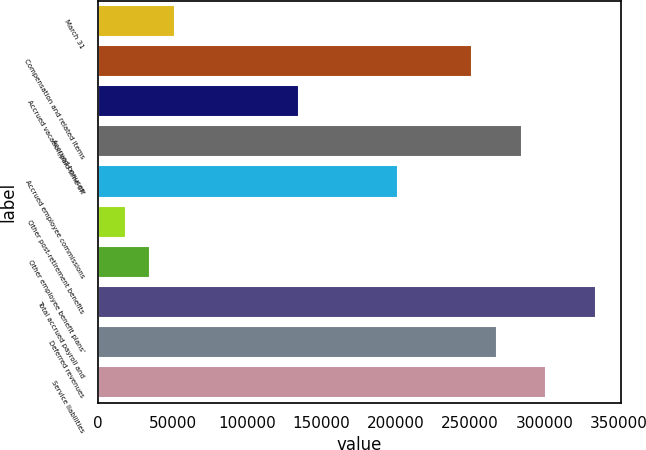Convert chart to OTSL. <chart><loc_0><loc_0><loc_500><loc_500><bar_chart><fcel>March 31<fcel>Compensation and related items<fcel>Accrued vacation/paid time off<fcel>Accrued bonuses<fcel>Accrued employee commissions<fcel>Other post-retirement benefits<fcel>Other employee benefit plans'<fcel>Total accrued payroll and<fcel>Deferred revenues<fcel>Service liabilities<nl><fcel>51723.7<fcel>251426<fcel>134933<fcel>284710<fcel>201501<fcel>18439.9<fcel>35081.8<fcel>334636<fcel>268068<fcel>301352<nl></chart> 